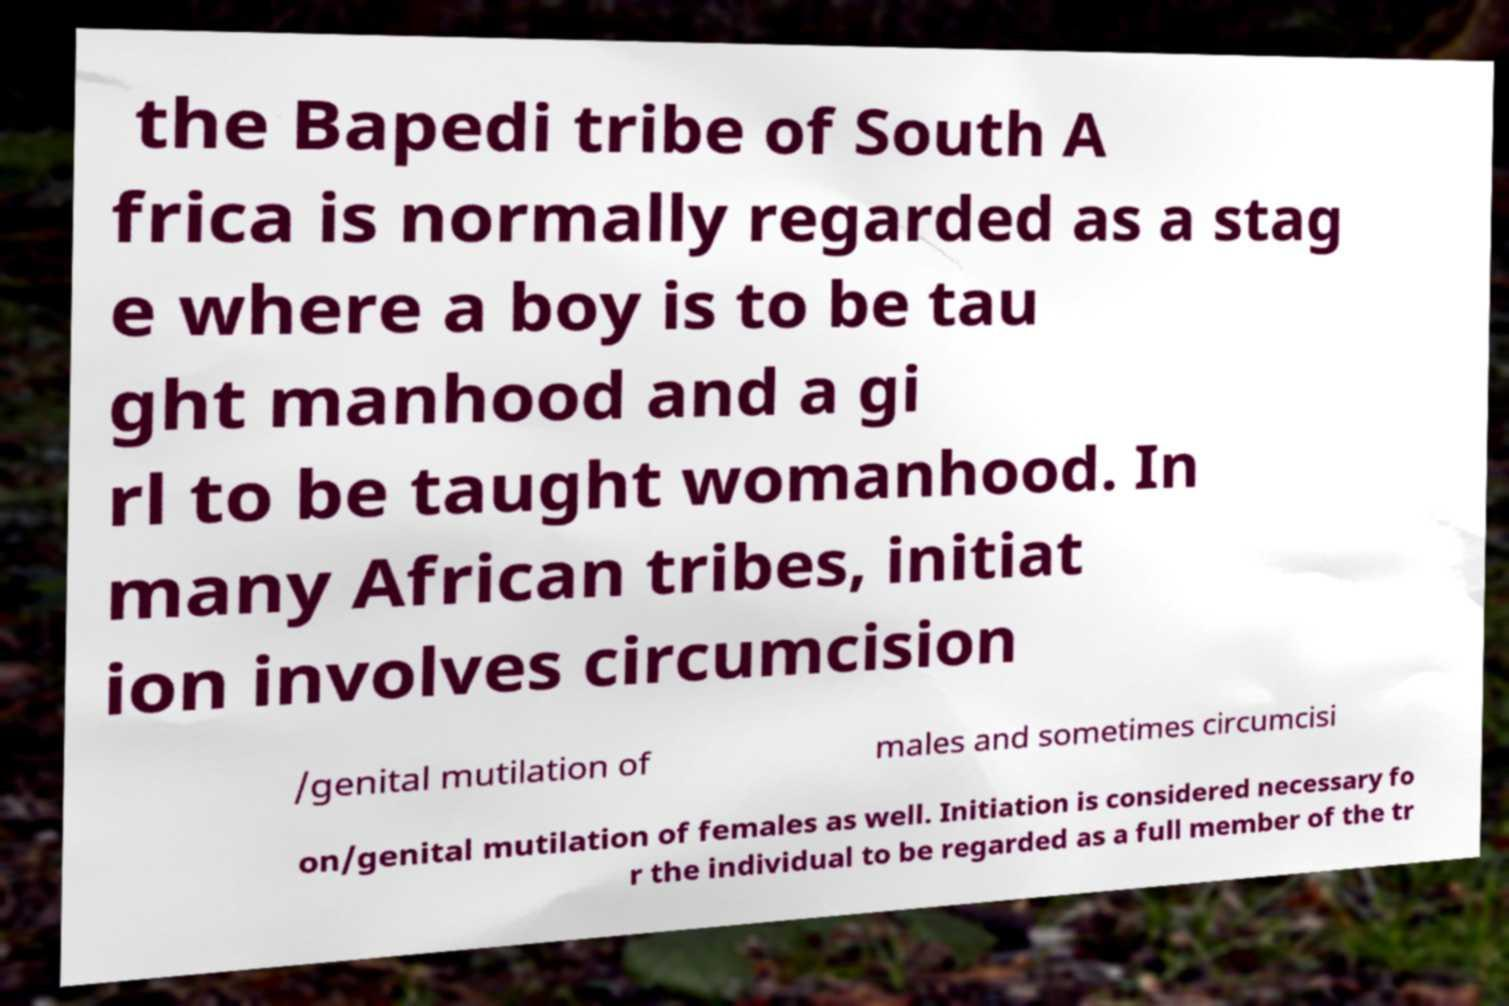Could you assist in decoding the text presented in this image and type it out clearly? the Bapedi tribe of South A frica is normally regarded as a stag e where a boy is to be tau ght manhood and a gi rl to be taught womanhood. In many African tribes, initiat ion involves circumcision /genital mutilation of males and sometimes circumcisi on/genital mutilation of females as well. Initiation is considered necessary fo r the individual to be regarded as a full member of the tr 